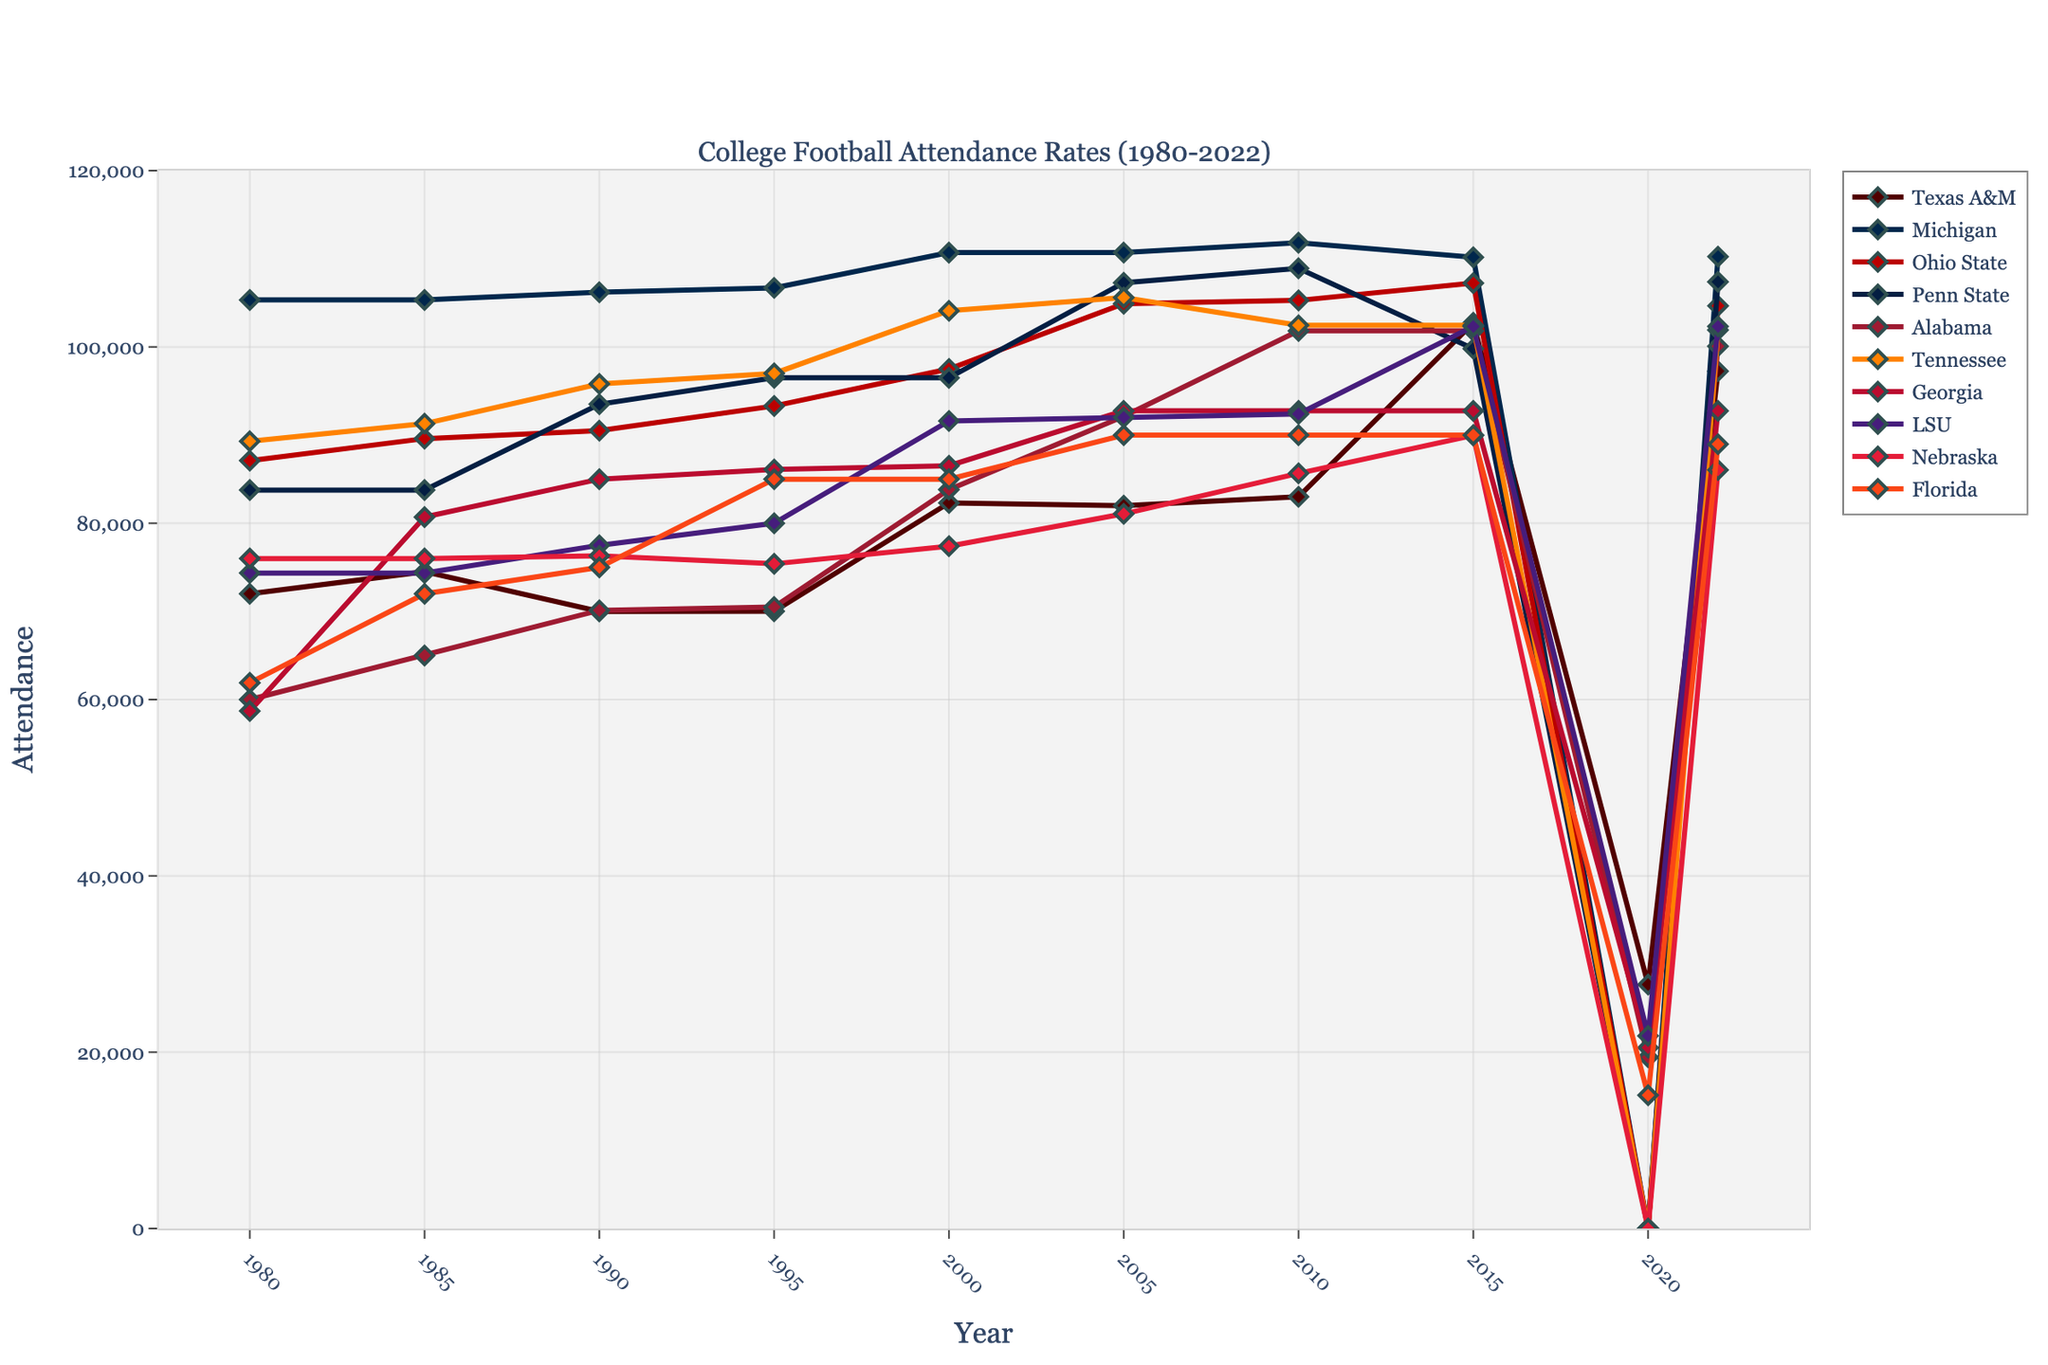what was the attendance for Texas A&M in 2010? Locate the "Texas A&M" line and follow it to the year 2010. The value is around 83,002.
Answer: 83,002 Which school had the highest attendance in 1985? Identify the markers for 1985, and look for the tallest peak at that year. Michigan had the highest attendance with around 105,330 attendees.
Answer: Michigan How did Texas A&M's attendance compare to Michigan's attendance in 2015? In 2015, Texas A&M's attendance was around 102,733, while Michigan's was around 110,168. Comparing these, Michigan's attendance was higher.
Answer: Michigan had higher attendance What’s the difference in attendance between Alabama and LSU in 1990? Find the attendance values for Alabama and LSU in 1990. Alabama had about 70,123, and LSU had about 77,500. The difference is 77,500 - 70,123 = 7,377.
Answer: 7,377 Which school has the highest regular attendance throughout the years shown? Look for the line that consistently lies the highest throughout the graph. Michigan has the highest regular attendance across the years.
Answer: Michigan What was the average attendance for Georgia from 1980 to 2022? To find the average, sum up the attendance figures for Georgia from 1980 to 2022 and divide by the number of years (10 data points). [(58,700 + 80,700 + 85,200 + 86,100 + 86,520 + 92,746 + 92,746 + 92,746 + 20,524 + 92,746) / 10 = 73,773.8.
Answer: 73,773.8 In which year did Texas A&M have the lowest attendance? Identify the lowest point/marker for the Texas A&M line. The lowest attendance was in 2020 with 27,675.
Answer: 2020 For how many years did Ohio State achieve an attendance higher than 100,000? Count the number of points exceeding 100,000 in the Ohio State line. Ohio State had an attendance greater than 100,000 in 4 years: 2005, 2010, 2015, and 2022.
Answer: 4 Between 1995 and 2000, which school showed the most increase in attendance? Compare the values from 1995 to 2000 for all schools and find the largest increase. Texas A&M had an increase from 70,016 to 82,300, which is the most significant increase.
Answer: Texas A&M 